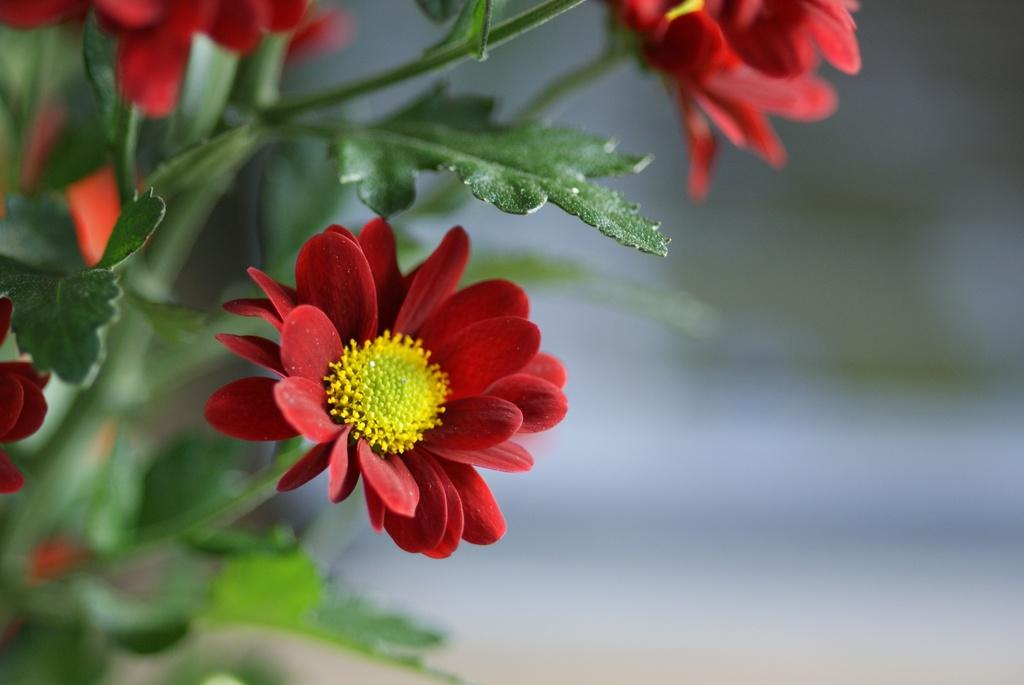What type of flowers are in the image? There are red color flowers in the image. What parts of the flowers are visible in the image? The flowers have stems and leaves. What type of feast is being prepared with the flowers in the image? There is no feast or preparation of any kind visible in the image; it only shows red color flowers with stems and leaves. 